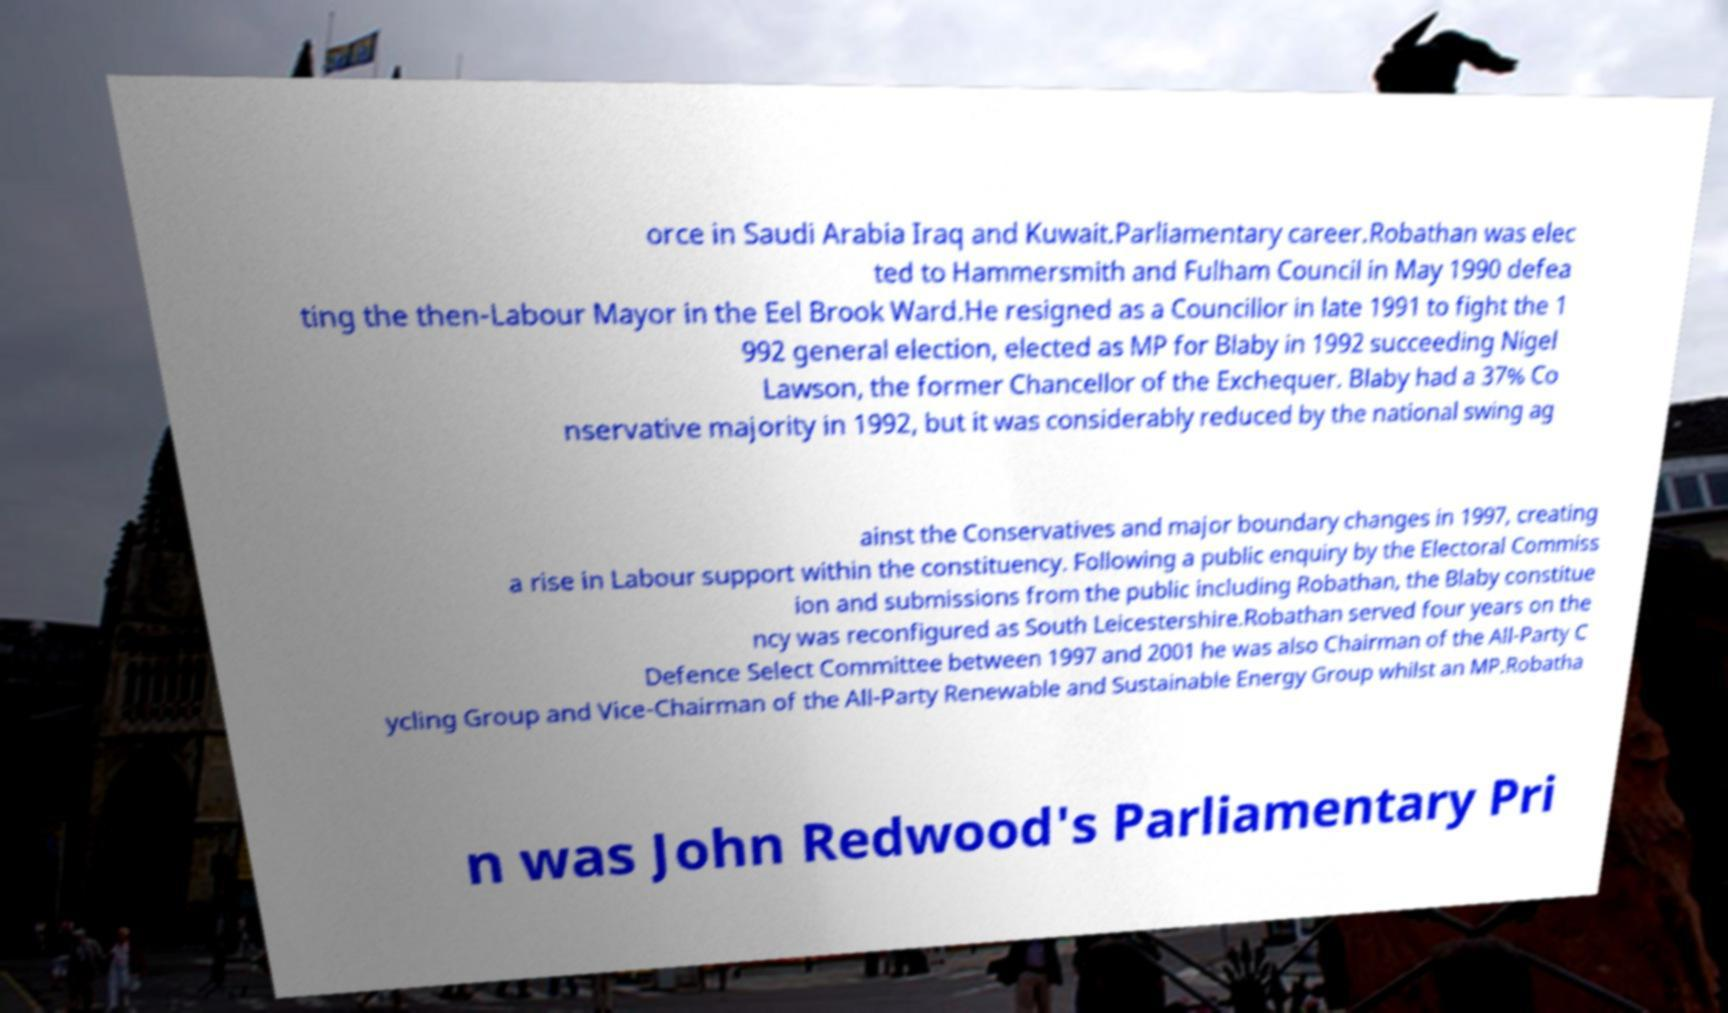Please read and relay the text visible in this image. What does it say? orce in Saudi Arabia Iraq and Kuwait.Parliamentary career.Robathan was elec ted to Hammersmith and Fulham Council in May 1990 defea ting the then-Labour Mayor in the Eel Brook Ward.He resigned as a Councillor in late 1991 to fight the 1 992 general election, elected as MP for Blaby in 1992 succeeding Nigel Lawson, the former Chancellor of the Exchequer. Blaby had a 37% Co nservative majority in 1992, but it was considerably reduced by the national swing ag ainst the Conservatives and major boundary changes in 1997, creating a rise in Labour support within the constituency. Following a public enquiry by the Electoral Commiss ion and submissions from the public including Robathan, the Blaby constitue ncy was reconfigured as South Leicestershire.Robathan served four years on the Defence Select Committee between 1997 and 2001 he was also Chairman of the All-Party C ycling Group and Vice-Chairman of the All-Party Renewable and Sustainable Energy Group whilst an MP.Robatha n was John Redwood's Parliamentary Pri 